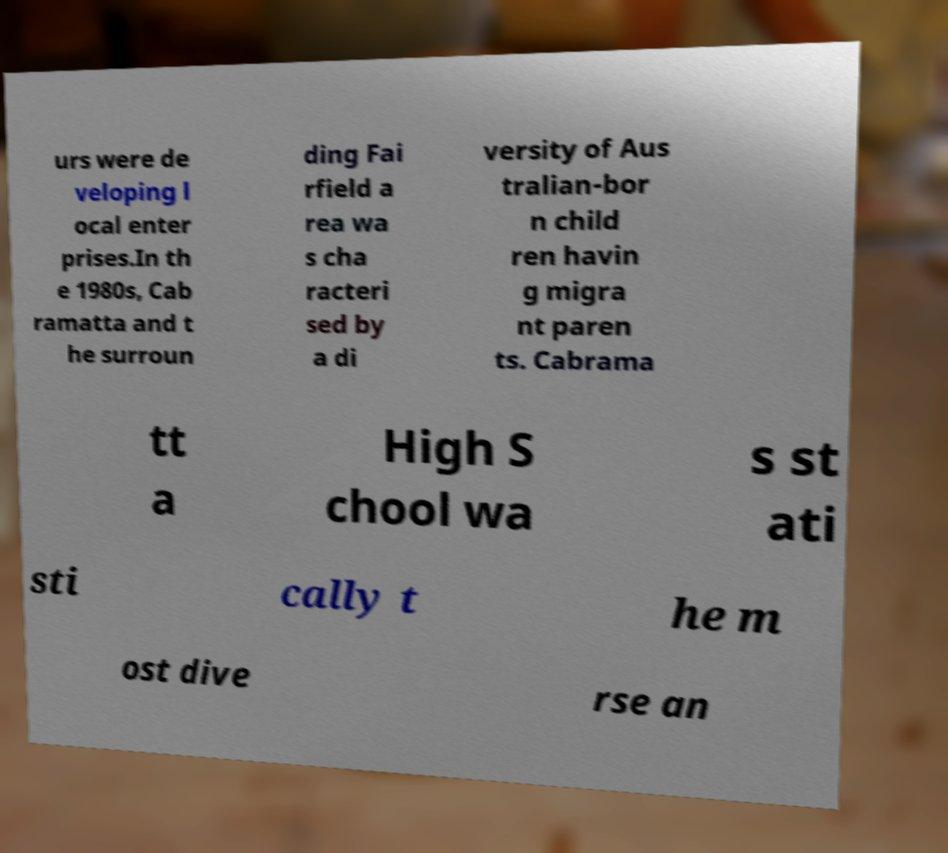Could you assist in decoding the text presented in this image and type it out clearly? urs were de veloping l ocal enter prises.In th e 1980s, Cab ramatta and t he surroun ding Fai rfield a rea wa s cha racteri sed by a di versity of Aus tralian-bor n child ren havin g migra nt paren ts. Cabrama tt a High S chool wa s st ati sti cally t he m ost dive rse an 